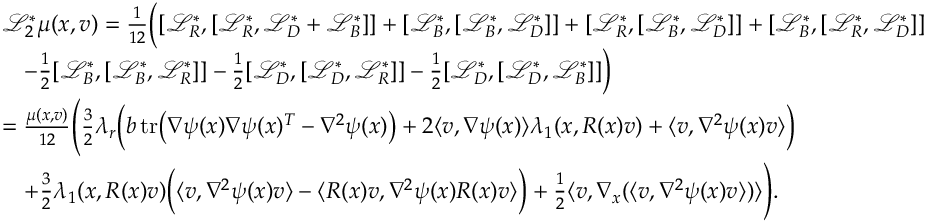Convert formula to latex. <formula><loc_0><loc_0><loc_500><loc_500>\begin{array} { r l } & { \mathcal { L } _ { 2 } ^ { * } \mu ( x , v ) = \frac { 1 } { 1 2 } \left ( [ \mathcal { L } _ { R } ^ { * } , [ \mathcal { L } _ { R } ^ { * } , \mathcal { L } _ { D } ^ { * } + \mathcal { L } _ { B } ^ { * } ] ] + [ \mathcal { L } _ { B } ^ { * } , [ \mathcal { L } _ { B } ^ { * } , \mathcal { L } _ { D } ^ { * } ] ] + [ \mathcal { L } _ { R } ^ { * } , [ \mathcal { L } _ { B } ^ { * } , \mathcal { L } _ { D } ^ { * } ] ] + [ \mathcal { L } _ { B } ^ { * } , [ \mathcal { L } _ { R } ^ { * } , \mathcal { L } _ { D } ^ { * } ] ] } \\ & { \quad - \frac { 1 } { 2 } [ \mathcal { L } _ { B } ^ { * } , [ \mathcal { L } _ { B } ^ { * } , \mathcal { L } _ { R } ^ { * } ] ] - \frac { 1 } { 2 } [ \mathcal { L } _ { D } ^ { * } , [ \mathcal { L } _ { D } ^ { * } , \mathcal { L } _ { R } ^ { * } ] ] - \frac { 1 } { 2 } [ \mathcal { L } _ { D } ^ { * } , [ \mathcal { L } _ { D } ^ { * } , \mathcal { L } _ { B } ^ { * } ] ] \right ) } \\ & { = \frac { \mu ( x , v ) } { 1 2 } \left ( \frac { 3 } { 2 } \lambda _ { r } \left ( b \, t r \left ( \nabla \psi ( x ) \nabla \psi ( x ) ^ { T } - \nabla ^ { 2 } \psi ( x ) \right ) + 2 \langle v , \nabla \psi ( x ) \rangle \lambda _ { 1 } ( x , R ( x ) v ) + \langle v , \nabla ^ { 2 } \psi ( x ) v \rangle \right ) } \\ & { \quad + \frac { 3 } { 2 } \lambda _ { 1 } ( x , R ( x ) v ) \left ( \langle v , \nabla ^ { 2 } \psi ( x ) v \rangle - \langle R ( x ) v , \nabla ^ { 2 } \psi ( x ) R ( x ) v \rangle \right ) + \frac { 1 } { 2 } \langle v , \nabla _ { x } ( \langle v , \nabla ^ { 2 } \psi ( x ) v \rangle ) \rangle \right ) . } \end{array}</formula> 